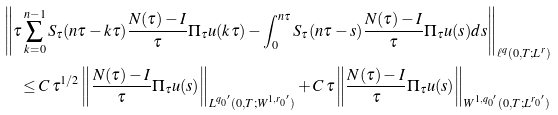<formula> <loc_0><loc_0><loc_500><loc_500>& \left \| \tau \sum _ { k = 0 } ^ { n - 1 } S _ { \tau } ( n \tau - k \tau ) \frac { N ( \tau ) - I } { \tau } \Pi _ { \tau } u ( k \tau ) - \int _ { 0 } ^ { n \tau } S _ { \tau } ( n \tau - s ) \frac { N ( \tau ) - I } { \tau } \Pi _ { \tau } u ( s ) d s \right \| _ { \ell ^ { q } ( 0 , T ; L ^ { r } ) } \\ & \quad \leq C \, \tau ^ { 1 / 2 } \left \| \frac { N ( \tau ) - I } { \tau } \Pi _ { \tau } u ( s ) \right \| _ { L ^ { { q _ { 0 } } ^ { \prime } } ( 0 , T ; W ^ { 1 , { r _ { 0 } } ^ { \prime } } ) } + C \, \tau \left \| \frac { N ( \tau ) - I } { \tau } \Pi _ { \tau } u ( s ) \right \| _ { W ^ { 1 , { q _ { 0 } } ^ { \prime } } ( 0 , T ; L ^ { { r _ { 0 } } ^ { \prime } } ) }</formula> 